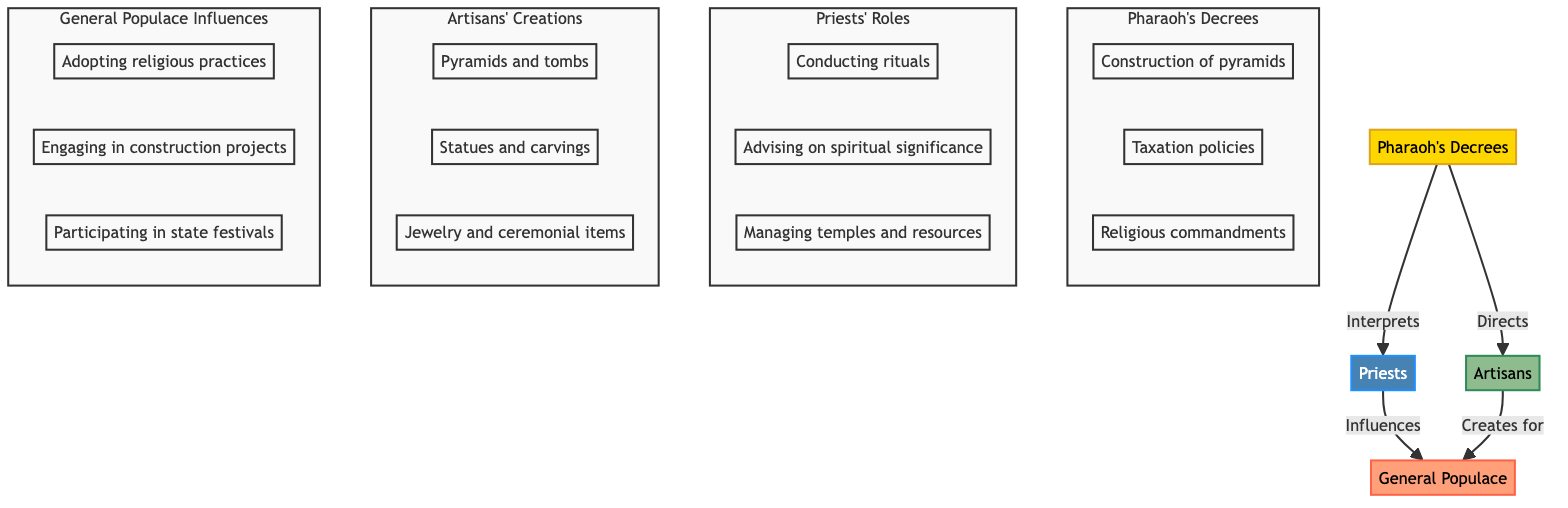What is the starting point of the cultural influence flow? The starting point is indicated as "Pharaoh's Decrees," which serves as the source of the cultural influence in the diagram.
Answer: Pharaoh's Decrees How many roles are defined for the Priests? In the diagram, there are three distinct roles outlined for the Priests, detailing their functions within the cultural influence flow.
Answer: 3 What influences the General Populace according to the diagram? The General Populace is influenced by the Priests and Artisans, as indicated by the arrows directing from both groups to the populace, representing multiple influences received.
Answer: Priests and Artisans Which group conducts rituals? According to the diagram, the role of conducting rituals is attributed specifically to the Priests within their defined set of roles, showing their religious significance.
Answer: Priests How many types of creations are attributed to the Artisans? There are three types of creations mentioned for the Artisans in the diagram, which highlights the various art forms and objects they produce following the Pharaoh's decrees.
Answer: 3 What is the relationship between the Pharaoh's Decrees and Artisans? The relationship is directional, with the Pharaoh's Decrees directly directing the Artisans, indicating that the artisans create based on commands from the Pharaoh.
Answer: Directs What does the General Populace adopt according to the diagram? The diagram indicates that the General Populace adopts "religious practices," showcasing their engagement with the cultural traditions established by the higher social strata.
Answer: Religious practices Which group manages temples and resources? The task of managing temples and resources is specifically assigned to the Priests, as depicted in their defined roles within the flow of cultural influence.
Answer: Priests How many edges are there leading to the General Populace? There are two edges leading to the General Populace—one from the Priests and another from the Artisans, demonstrating the dual influence on the populace from both groups.
Answer: 2 